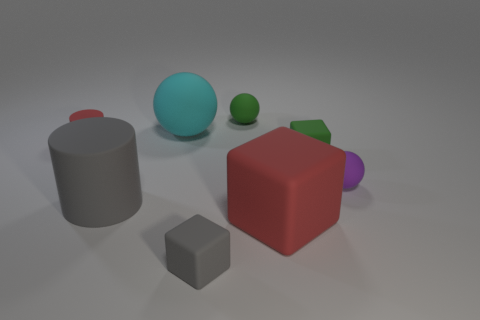Add 1 tiny red matte cylinders. How many objects exist? 9 Subtract all cubes. How many objects are left? 5 Add 3 small spheres. How many small spheres exist? 5 Subtract 0 yellow cylinders. How many objects are left? 8 Subtract all cubes. Subtract all purple rubber objects. How many objects are left? 4 Add 3 cylinders. How many cylinders are left? 5 